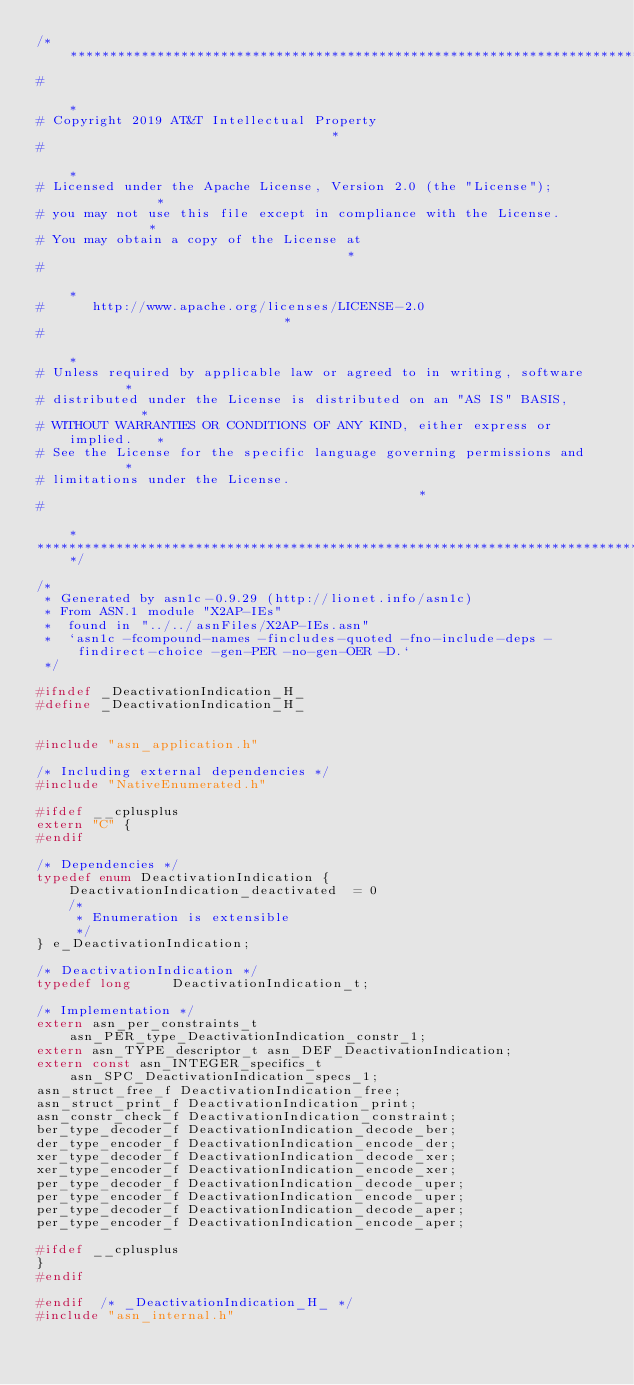Convert code to text. <code><loc_0><loc_0><loc_500><loc_500><_C_>/*****************************************************************************
#                                                                            *
# Copyright 2019 AT&T Intellectual Property                                  *
#                                                                            *
# Licensed under the Apache License, Version 2.0 (the "License");            *
# you may not use this file except in compliance with the License.           *
# You may obtain a copy of the License at                                    *
#                                                                            *
#      http://www.apache.org/licenses/LICENSE-2.0                            *
#                                                                            *
# Unless required by applicable law or agreed to in writing, software        *
# distributed under the License is distributed on an "AS IS" BASIS,          *
# WITHOUT WARRANTIES OR CONDITIONS OF ANY KIND, either express or implied.   *
# See the License for the specific language governing permissions and        *
# limitations under the License.                                             *
#                                                                            *
******************************************************************************/

/*
 * Generated by asn1c-0.9.29 (http://lionet.info/asn1c)
 * From ASN.1 module "X2AP-IEs"
 * 	found in "../../asnFiles/X2AP-IEs.asn"
 * 	`asn1c -fcompound-names -fincludes-quoted -fno-include-deps -findirect-choice -gen-PER -no-gen-OER -D.`
 */

#ifndef	_DeactivationIndication_H_
#define	_DeactivationIndication_H_


#include "asn_application.h"

/* Including external dependencies */
#include "NativeEnumerated.h"

#ifdef __cplusplus
extern "C" {
#endif

/* Dependencies */
typedef enum DeactivationIndication {
	DeactivationIndication_deactivated	= 0
	/*
	 * Enumeration is extensible
	 */
} e_DeactivationIndication;

/* DeactivationIndication */
typedef long	 DeactivationIndication_t;

/* Implementation */
extern asn_per_constraints_t asn_PER_type_DeactivationIndication_constr_1;
extern asn_TYPE_descriptor_t asn_DEF_DeactivationIndication;
extern const asn_INTEGER_specifics_t asn_SPC_DeactivationIndication_specs_1;
asn_struct_free_f DeactivationIndication_free;
asn_struct_print_f DeactivationIndication_print;
asn_constr_check_f DeactivationIndication_constraint;
ber_type_decoder_f DeactivationIndication_decode_ber;
der_type_encoder_f DeactivationIndication_encode_der;
xer_type_decoder_f DeactivationIndication_decode_xer;
xer_type_encoder_f DeactivationIndication_encode_xer;
per_type_decoder_f DeactivationIndication_decode_uper;
per_type_encoder_f DeactivationIndication_encode_uper;
per_type_decoder_f DeactivationIndication_decode_aper;
per_type_encoder_f DeactivationIndication_encode_aper;

#ifdef __cplusplus
}
#endif

#endif	/* _DeactivationIndication_H_ */
#include "asn_internal.h"
</code> 